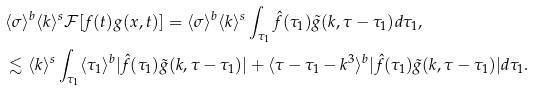<formula> <loc_0><loc_0><loc_500><loc_500>& \langle \sigma \rangle ^ { b } \langle k \rangle ^ { s } \mathcal { F } [ f ( t ) g ( x , t ) ] = \langle \sigma \rangle ^ { b } \langle k \rangle ^ { s } \int _ { \tau _ { 1 } } \hat { f } ( \tau _ { 1 } ) \tilde { g } ( k , \tau - \tau _ { 1 } ) d \tau _ { 1 } , \\ & \lesssim \langle k \rangle ^ { s } \int _ { \tau _ { 1 } } \langle \tau _ { 1 } \rangle ^ { b } | \hat { f } ( \tau _ { 1 } ) \tilde { g } ( k , \tau - \tau _ { 1 } ) | + \langle \tau - \tau _ { 1 } - k ^ { 3 } \rangle ^ { b } | \hat { f } ( \tau _ { 1 } ) \tilde { g } ( k , \tau - \tau _ { 1 } ) | d \tau _ { 1 } .</formula> 